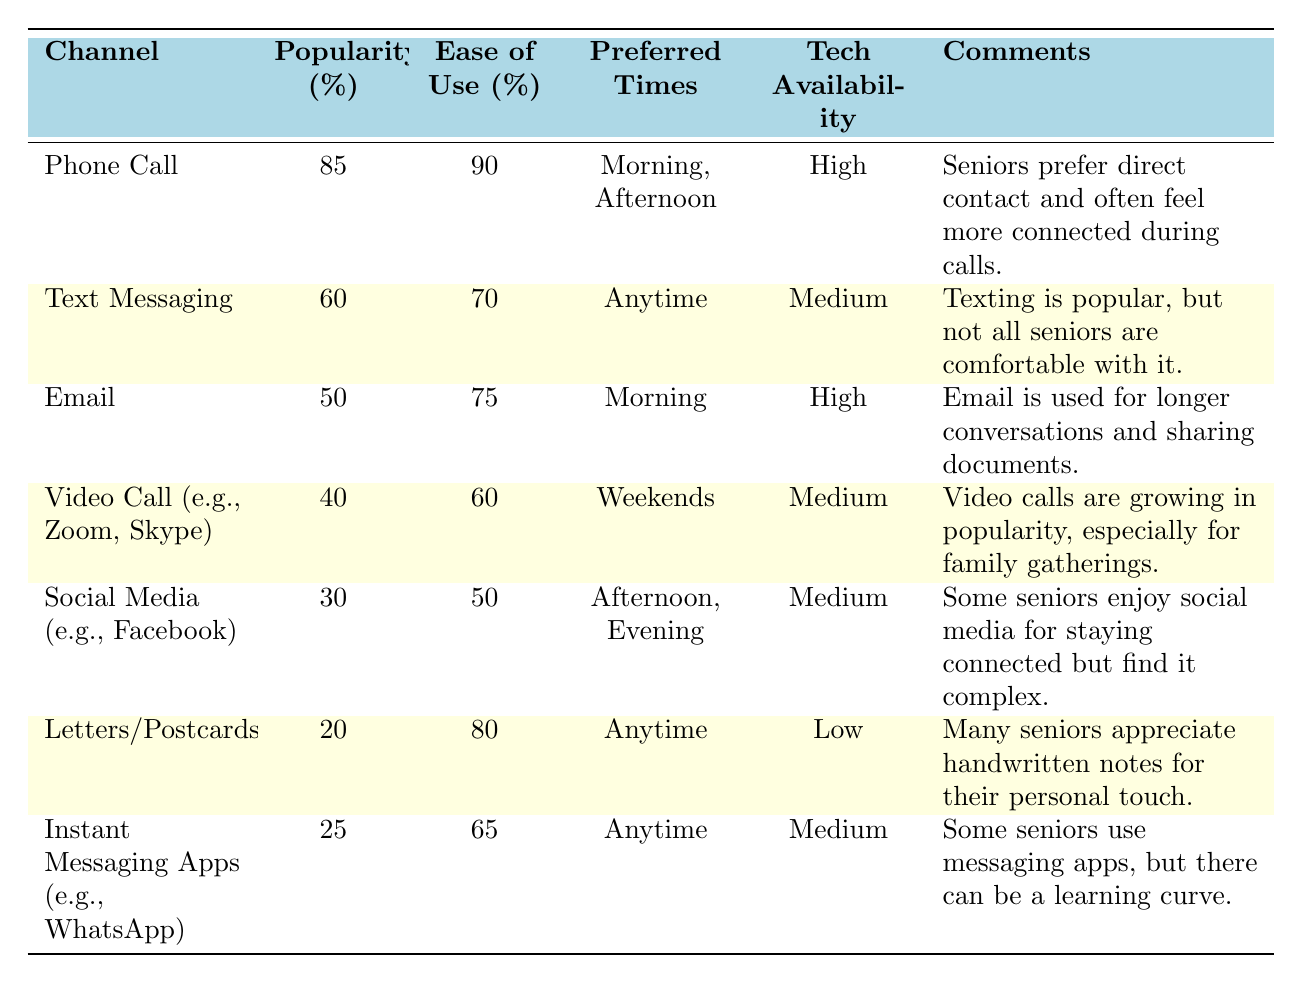What is the most popular communication channel among seniors? The table shows that "Phone Call" has the highest popularity percentage at 85%.
Answer: Phone Call Which communication channel has the highest ease of use rating? According to the table, "Phone Call" has the highest ease of use rating at 90%.
Answer: Phone Call What are the preferred times for email communication? The preferred times for email communication listed in the table are "Morning."
Answer: Morning Is there any channel with low tech availability and high ease of use? Yes, "Letters/Postcards" have low tech availability with an ease of use rating of 80%.
Answer: Yes How many channels have a popularity rating above 50%? There are three channels: "Phone Call" (85%), "Text Messaging" (60%), and "Email" (50%).
Answer: Three What is the average ease of use rating for all communication channels? To calculate the average ease of use: (90 + 70 + 75 + 60 + 50 + 80 + 65) = 510 total; there are 7 channels, so 510/7 = 72.86 (approximately 73).
Answer: 73 Which channel is preferred anytime and has a popularity rating of 25%? "Instant Messaging Apps (e.g., WhatsApp)" is preferred anytime and has a popularity rating of 25%.
Answer: Instant Messaging Apps Is video calling more popular than social media among seniors? No, video calling (40%) is less popular than social media (30%).
Answer: No What percentage of seniors find text messaging easy to use? The table indicates that 70% of seniors find text messaging easy to use.
Answer: 70% Which two channels have the same tech availability? "Text Messaging" and "Video Call" both have medium tech availability.
Answer: Text Messaging and Video Call 